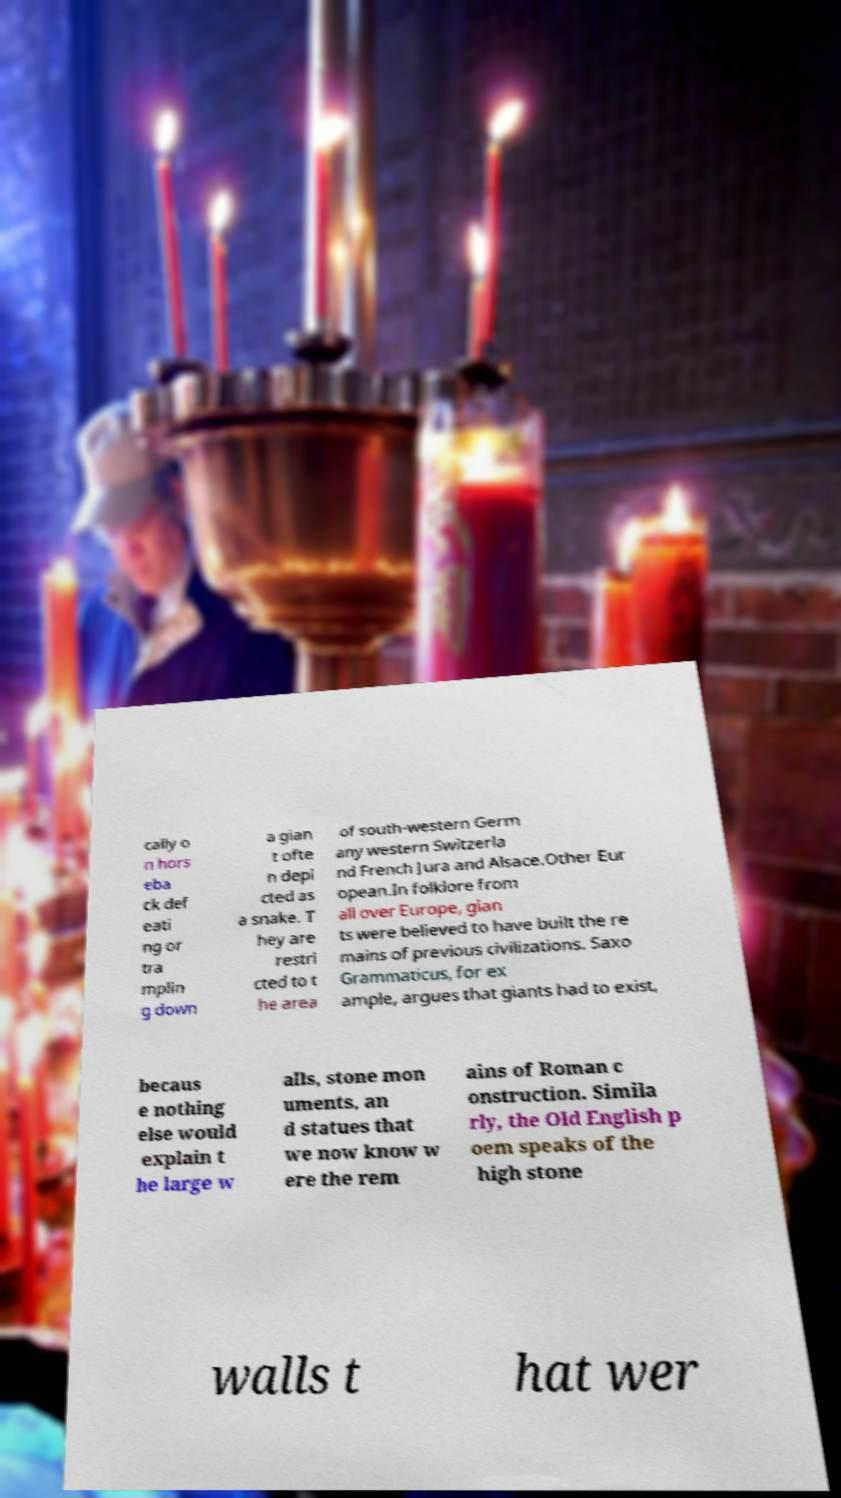Please identify and transcribe the text found in this image. cally o n hors eba ck def eati ng or tra mplin g down a gian t ofte n depi cted as a snake. T hey are restri cted to t he area of south-western Germ any western Switzerla nd French Jura and Alsace.Other Eur opean.In folklore from all over Europe, gian ts were believed to have built the re mains of previous civilizations. Saxo Grammaticus, for ex ample, argues that giants had to exist, becaus e nothing else would explain t he large w alls, stone mon uments, an d statues that we now know w ere the rem ains of Roman c onstruction. Simila rly, the Old English p oem speaks of the high stone walls t hat wer 